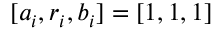Convert formula to latex. <formula><loc_0><loc_0><loc_500><loc_500>[ a _ { i } , r _ { i } , b _ { i } ] = [ 1 , 1 , 1 ]</formula> 